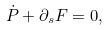Convert formula to latex. <formula><loc_0><loc_0><loc_500><loc_500>\dot { P } + \partial _ { s } F = 0 ,</formula> 